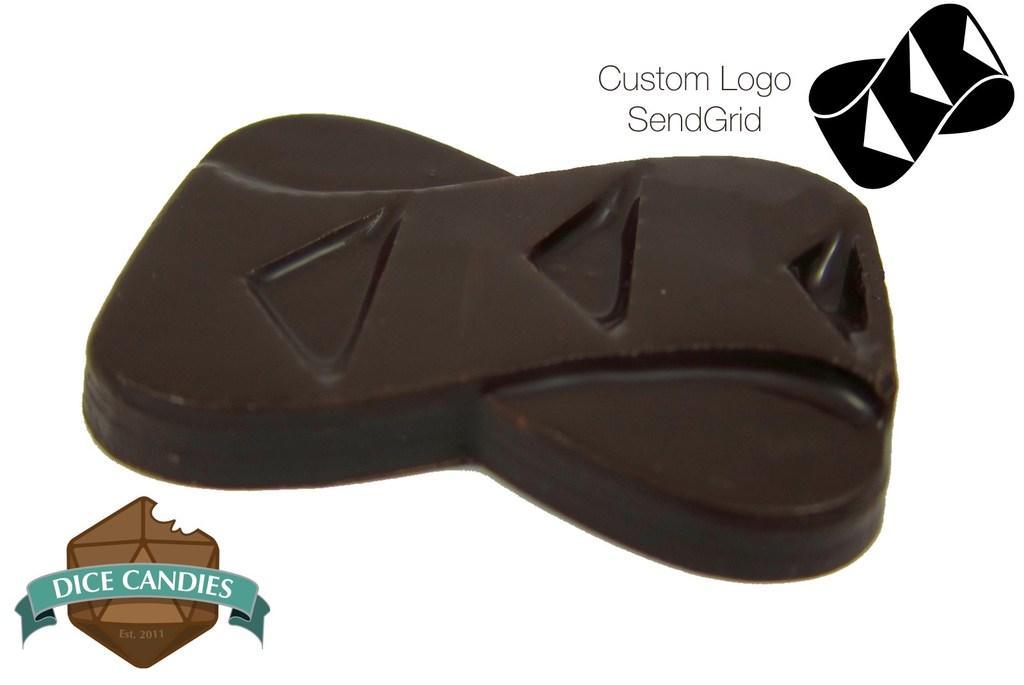Can you describe this image briefly? In this image, we can see a chocolate bar. On the right side top and left side bottom of the image, we can see logos and some text. 